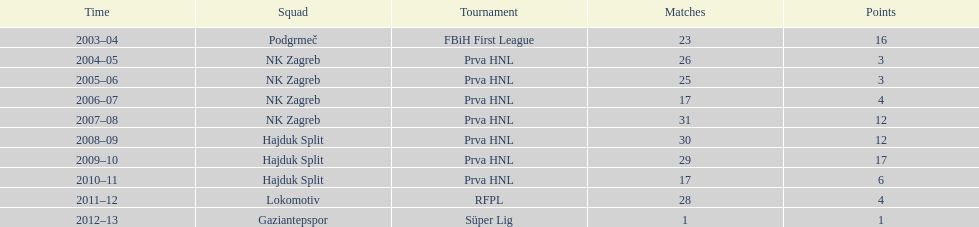Considering a limit of 26 apps, how many goals were scored in the 2004-2005 timeframe? 3. 